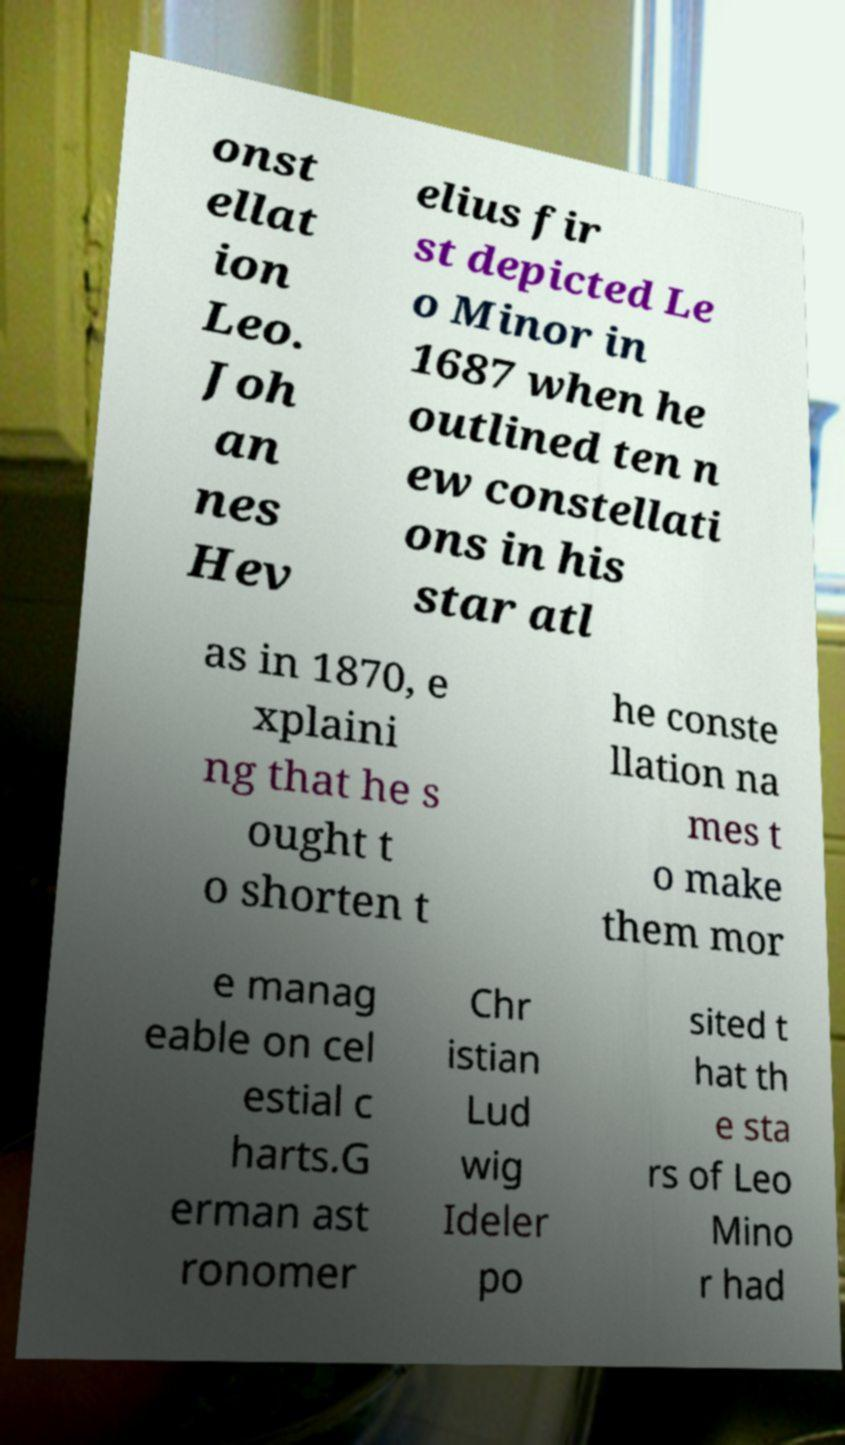Can you accurately transcribe the text from the provided image for me? onst ellat ion Leo. Joh an nes Hev elius fir st depicted Le o Minor in 1687 when he outlined ten n ew constellati ons in his star atl as in 1870, e xplaini ng that he s ought t o shorten t he conste llation na mes t o make them mor e manag eable on cel estial c harts.G erman ast ronomer Chr istian Lud wig Ideler po sited t hat th e sta rs of Leo Mino r had 